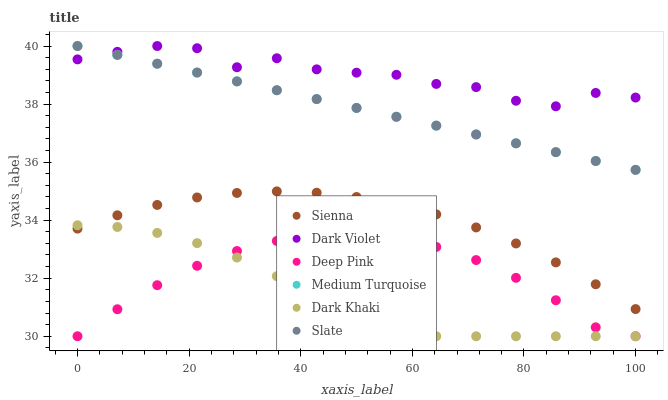Does Dark Khaki have the minimum area under the curve?
Answer yes or no. Yes. Does Dark Violet have the maximum area under the curve?
Answer yes or no. Yes. Does Deep Pink have the minimum area under the curve?
Answer yes or no. No. Does Deep Pink have the maximum area under the curve?
Answer yes or no. No. Is Slate the smoothest?
Answer yes or no. Yes. Is Dark Violet the roughest?
Answer yes or no. Yes. Is Deep Pink the smoothest?
Answer yes or no. No. Is Deep Pink the roughest?
Answer yes or no. No. Does Dark Khaki have the lowest value?
Answer yes or no. Yes. Does Slate have the lowest value?
Answer yes or no. No. Does Medium Turquoise have the highest value?
Answer yes or no. Yes. Does Deep Pink have the highest value?
Answer yes or no. No. Is Dark Khaki less than Medium Turquoise?
Answer yes or no. Yes. Is Slate greater than Dark Khaki?
Answer yes or no. Yes. Does Dark Khaki intersect Deep Pink?
Answer yes or no. Yes. Is Dark Khaki less than Deep Pink?
Answer yes or no. No. Is Dark Khaki greater than Deep Pink?
Answer yes or no. No. Does Dark Khaki intersect Medium Turquoise?
Answer yes or no. No. 